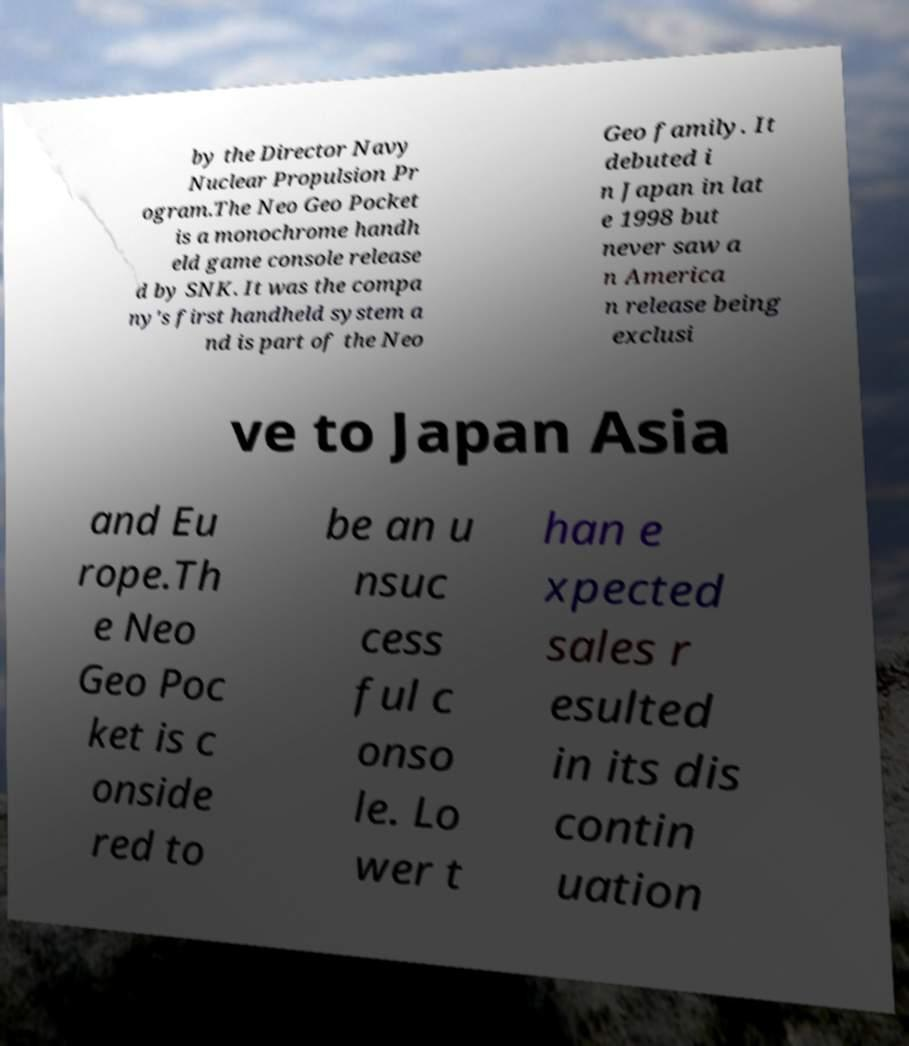For documentation purposes, I need the text within this image transcribed. Could you provide that? by the Director Navy Nuclear Propulsion Pr ogram.The Neo Geo Pocket is a monochrome handh eld game console release d by SNK. It was the compa ny's first handheld system a nd is part of the Neo Geo family. It debuted i n Japan in lat e 1998 but never saw a n America n release being exclusi ve to Japan Asia and Eu rope.Th e Neo Geo Poc ket is c onside red to be an u nsuc cess ful c onso le. Lo wer t han e xpected sales r esulted in its dis contin uation 